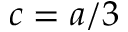<formula> <loc_0><loc_0><loc_500><loc_500>c = a / 3</formula> 